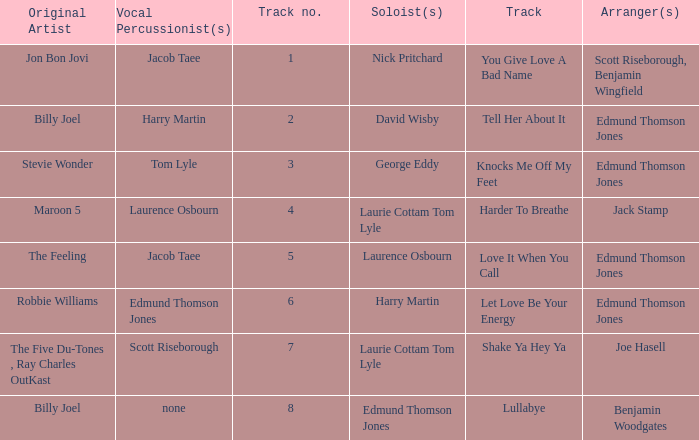Who were the original artist(s) when jack stamp arranged? Maroon 5. 